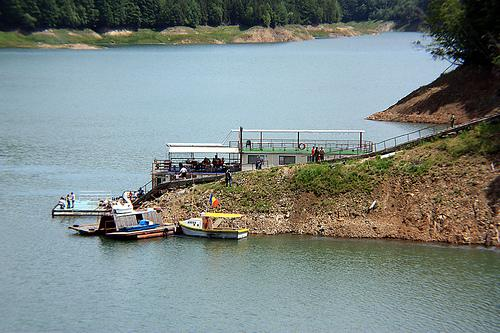People standing on something solid furthest into and above water stand on what? dock 